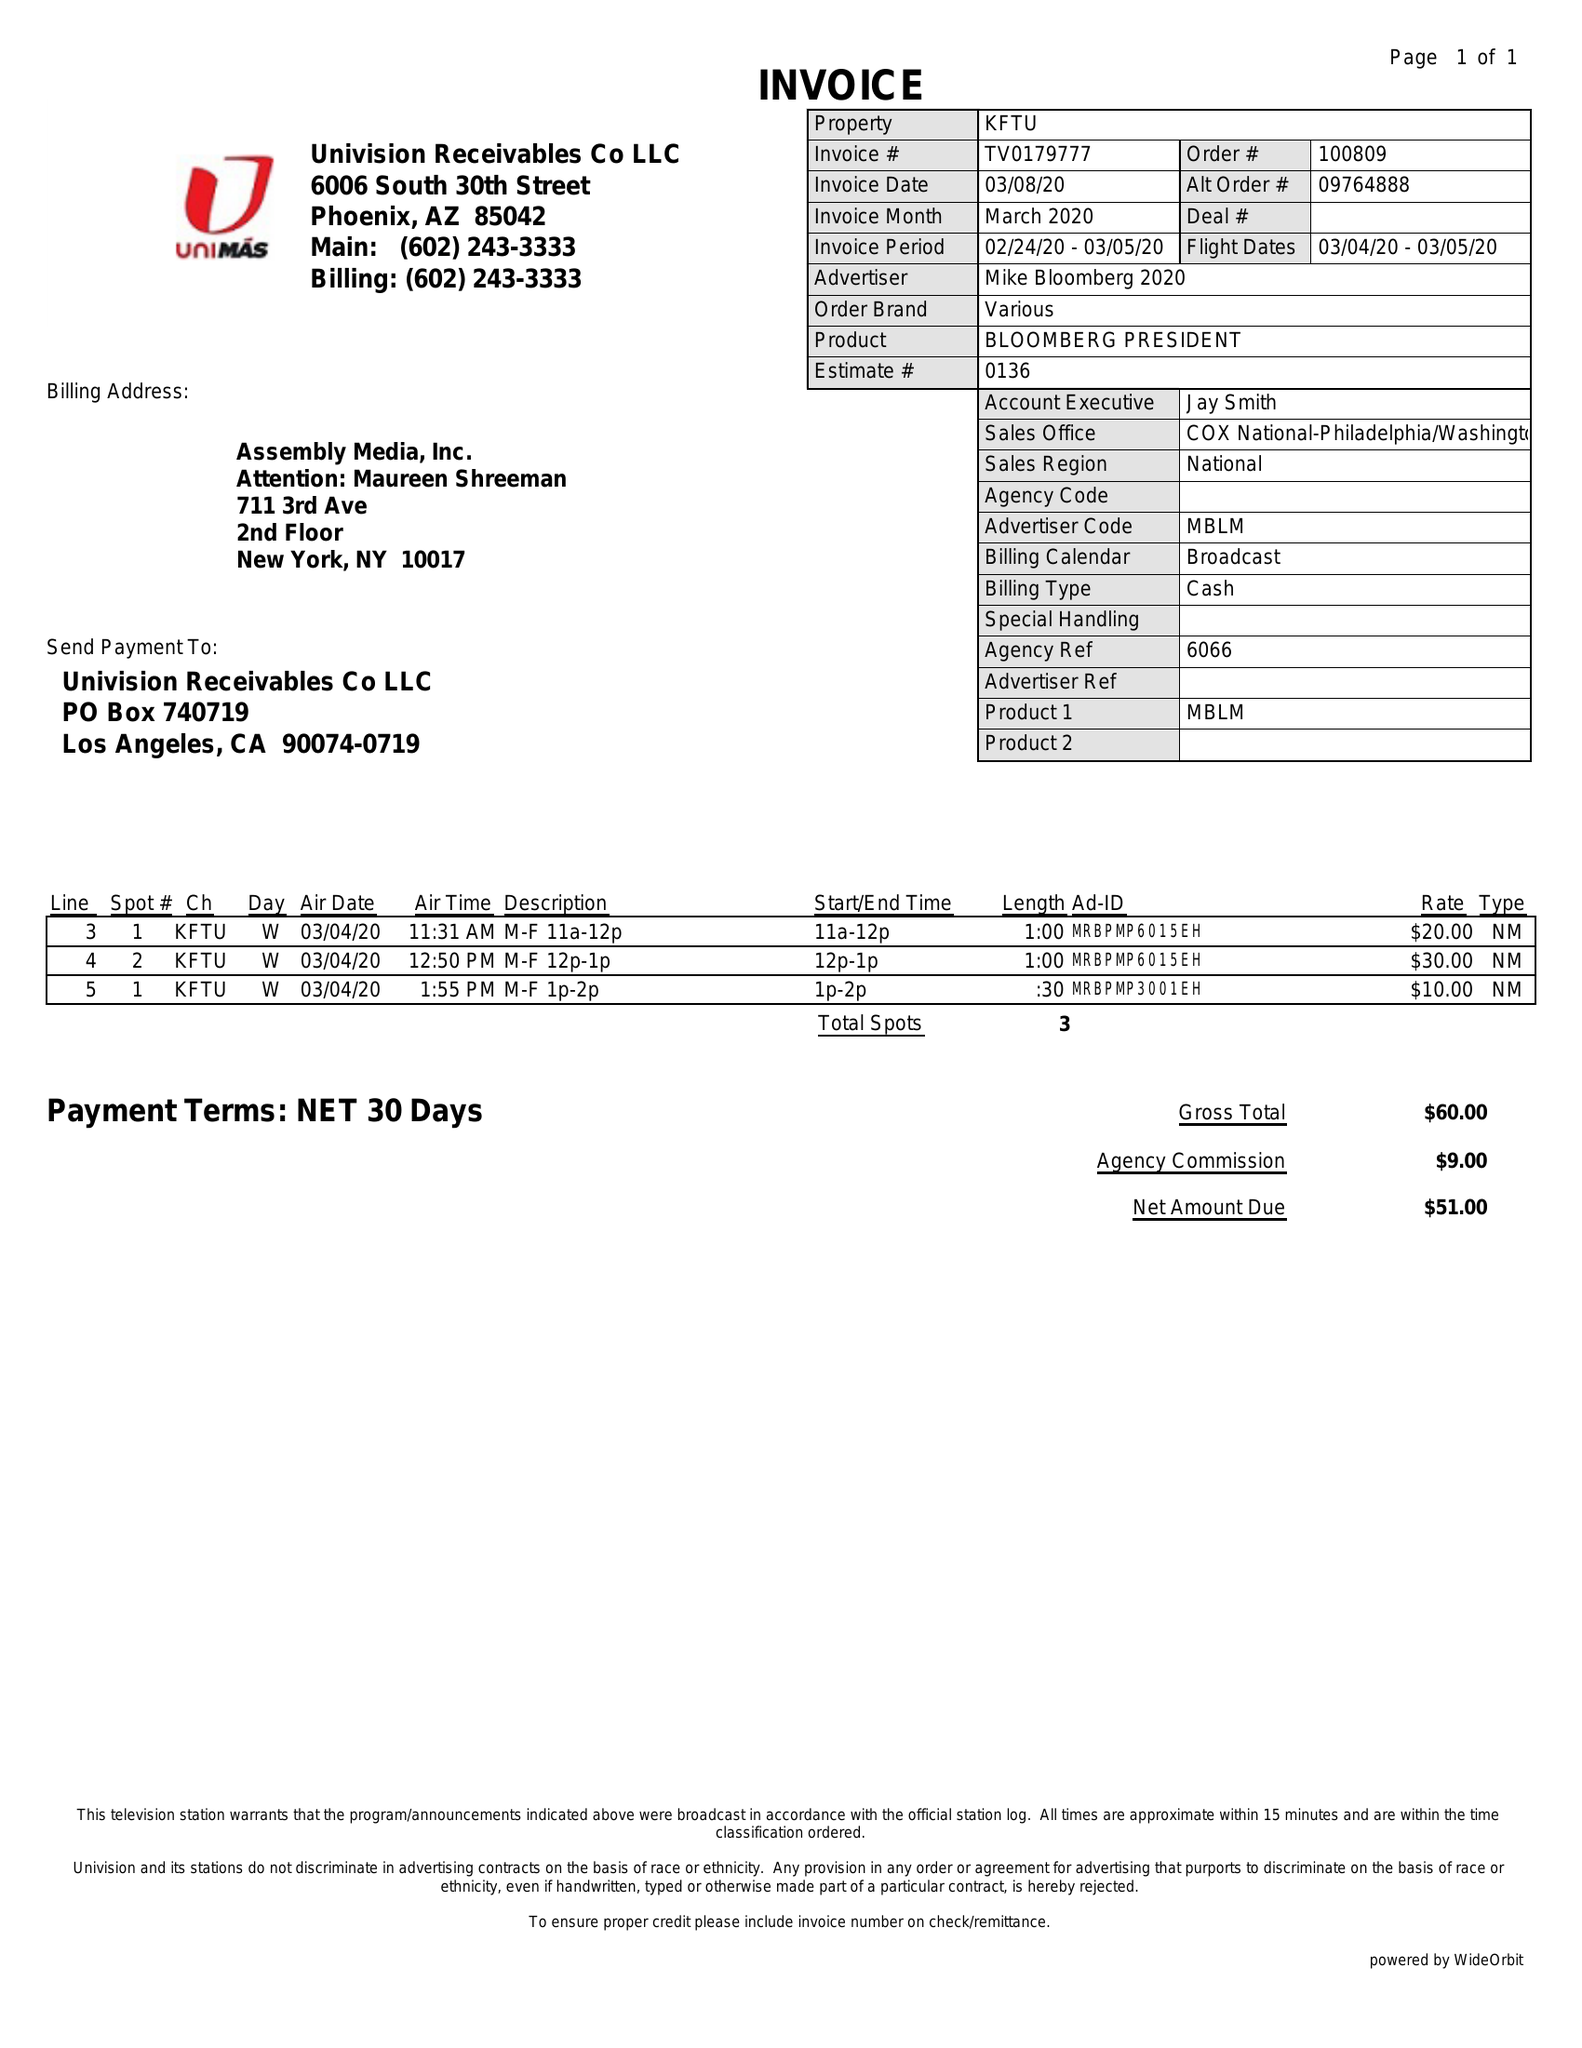What is the value for the contract_num?
Answer the question using a single word or phrase. TV0179777 